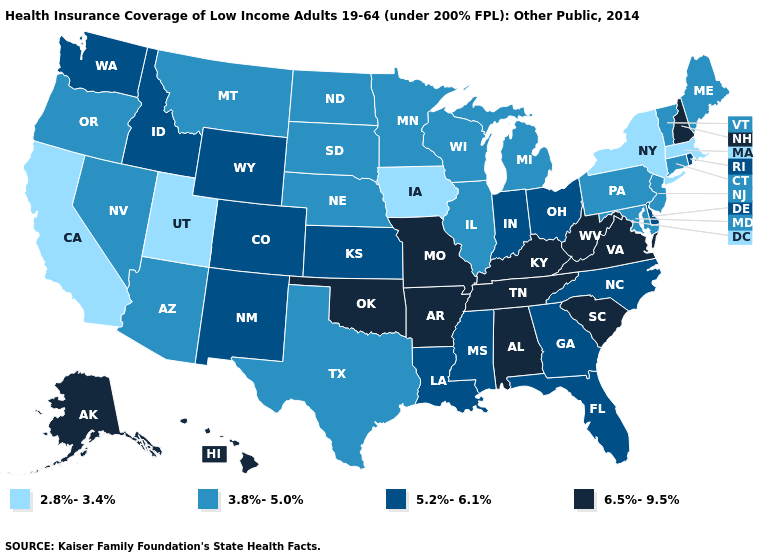Does the map have missing data?
Short answer required. No. Name the states that have a value in the range 5.2%-6.1%?
Be succinct. Colorado, Delaware, Florida, Georgia, Idaho, Indiana, Kansas, Louisiana, Mississippi, New Mexico, North Carolina, Ohio, Rhode Island, Washington, Wyoming. What is the value of Wisconsin?
Concise answer only. 3.8%-5.0%. Name the states that have a value in the range 3.8%-5.0%?
Quick response, please. Arizona, Connecticut, Illinois, Maine, Maryland, Michigan, Minnesota, Montana, Nebraska, Nevada, New Jersey, North Dakota, Oregon, Pennsylvania, South Dakota, Texas, Vermont, Wisconsin. What is the highest value in states that border Maryland?
Write a very short answer. 6.5%-9.5%. Among the states that border Rhode Island , does Massachusetts have the lowest value?
Short answer required. Yes. What is the value of Connecticut?
Quick response, please. 3.8%-5.0%. Name the states that have a value in the range 3.8%-5.0%?
Concise answer only. Arizona, Connecticut, Illinois, Maine, Maryland, Michigan, Minnesota, Montana, Nebraska, Nevada, New Jersey, North Dakota, Oregon, Pennsylvania, South Dakota, Texas, Vermont, Wisconsin. Name the states that have a value in the range 2.8%-3.4%?
Answer briefly. California, Iowa, Massachusetts, New York, Utah. Which states have the lowest value in the USA?
Give a very brief answer. California, Iowa, Massachusetts, New York, Utah. Does the first symbol in the legend represent the smallest category?
Answer briefly. Yes. Name the states that have a value in the range 3.8%-5.0%?
Concise answer only. Arizona, Connecticut, Illinois, Maine, Maryland, Michigan, Minnesota, Montana, Nebraska, Nevada, New Jersey, North Dakota, Oregon, Pennsylvania, South Dakota, Texas, Vermont, Wisconsin. Does the map have missing data?
Answer briefly. No. What is the highest value in the USA?
Short answer required. 6.5%-9.5%. What is the value of Georgia?
Short answer required. 5.2%-6.1%. 